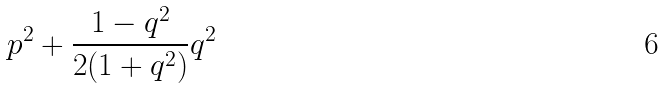Convert formula to latex. <formula><loc_0><loc_0><loc_500><loc_500>p ^ { 2 } + \frac { 1 - q ^ { 2 } } { 2 ( 1 + q ^ { 2 } ) } q ^ { 2 }</formula> 